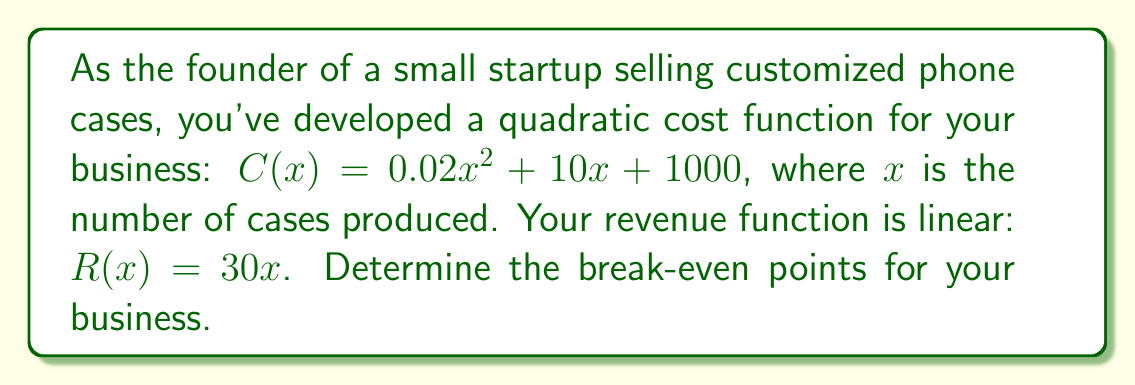Can you solve this math problem? To find the break-even points, we need to solve the equation where revenue equals cost:

1) Set up the equation:
   $R(x) = C(x)$
   $30x = 0.02x^2 + 10x + 1000$

2) Rearrange to standard quadratic form:
   $0.02x^2 + 10x + 1000 - 30x = 0$
   $0.02x^2 - 20x + 1000 = 0$

3) Multiply all terms by 100 to eliminate decimals:
   $2x^2 - 2000x + 100000 = 0$

4) Use the quadratic formula: $x = \frac{-b \pm \sqrt{b^2 - 4ac}}{2a}$
   Where $a = 2$, $b = -2000$, and $c = 100000$

5) Substitute into the formula:
   $$x = \frac{2000 \pm \sqrt{(-2000)^2 - 4(2)(100000)}}{2(2)}$$

6) Simplify:
   $$x = \frac{2000 \pm \sqrt{4000000 - 800000}}{4}$$
   $$x = \frac{2000 \pm \sqrt{3200000}}{4}$$
   $$x = \frac{2000 \pm 1788.85}{4}$$

7) Solve for both roots:
   $$x_1 = \frac{2000 + 1788.85}{4} \approx 947.21$$
   $$x_2 = \frac{2000 - 1788.85}{4} \approx 52.79$$

Therefore, the break-even points occur at approximately 53 units and 947 units.
Answer: 53 units and 947 units (rounded to nearest whole number) 